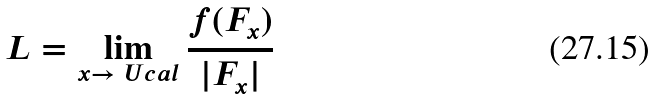<formula> <loc_0><loc_0><loc_500><loc_500>L = \lim _ { x \to \ U c a l } \frac { f ( F _ { x } ) } { | F _ { x } | }</formula> 